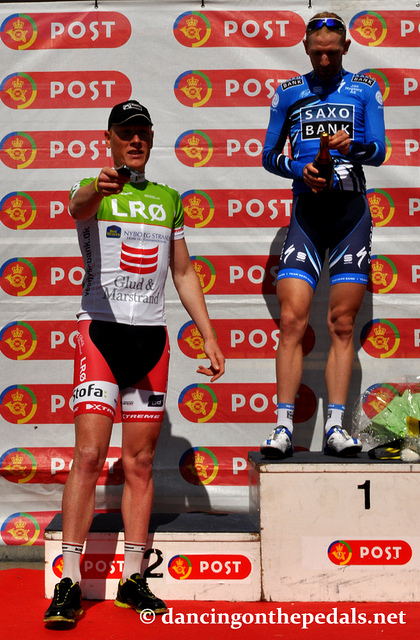Identify and read out the text in this image. POST POST SAXO LR0 POST 2 Glud &amp; Marstrand POST POST POST POST dancingonthepedals.net 1 P P P P P BANK POST POST P PO PO POS PO StoFa PO P &amp; Glud 